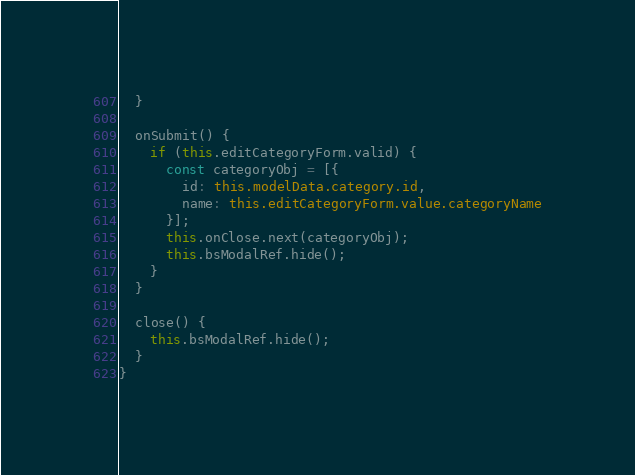Convert code to text. <code><loc_0><loc_0><loc_500><loc_500><_TypeScript_>  }

  onSubmit() {
    if (this.editCategoryForm.valid) {
      const categoryObj = [{
        id: this.modelData.category.id, 
        name: this.editCategoryForm.value.categoryName
      }];
      this.onClose.next(categoryObj);
      this.bsModalRef.hide();
    }
  }

  close() {
    this.bsModalRef.hide();
  }
}

</code> 